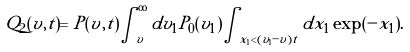<formula> <loc_0><loc_0><loc_500><loc_500>Q _ { 2 } ( v , t ) = P ( v , t ) \int _ { v } ^ { \infty } d v _ { 1 } P _ { 0 } ( v _ { 1 } ) \int _ { x _ { 1 } < ( v _ { 1 } - v ) t } d x _ { 1 } \exp ( - x _ { 1 } ) .</formula> 